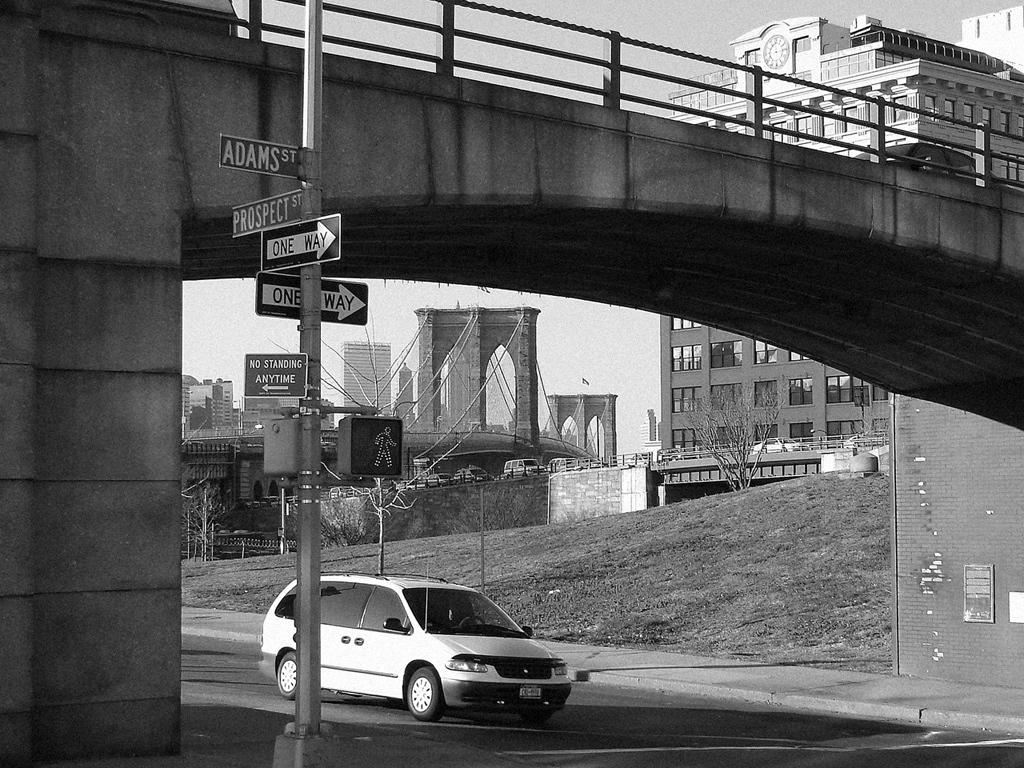How many one way streets are there?
Offer a very short reply. 2. 